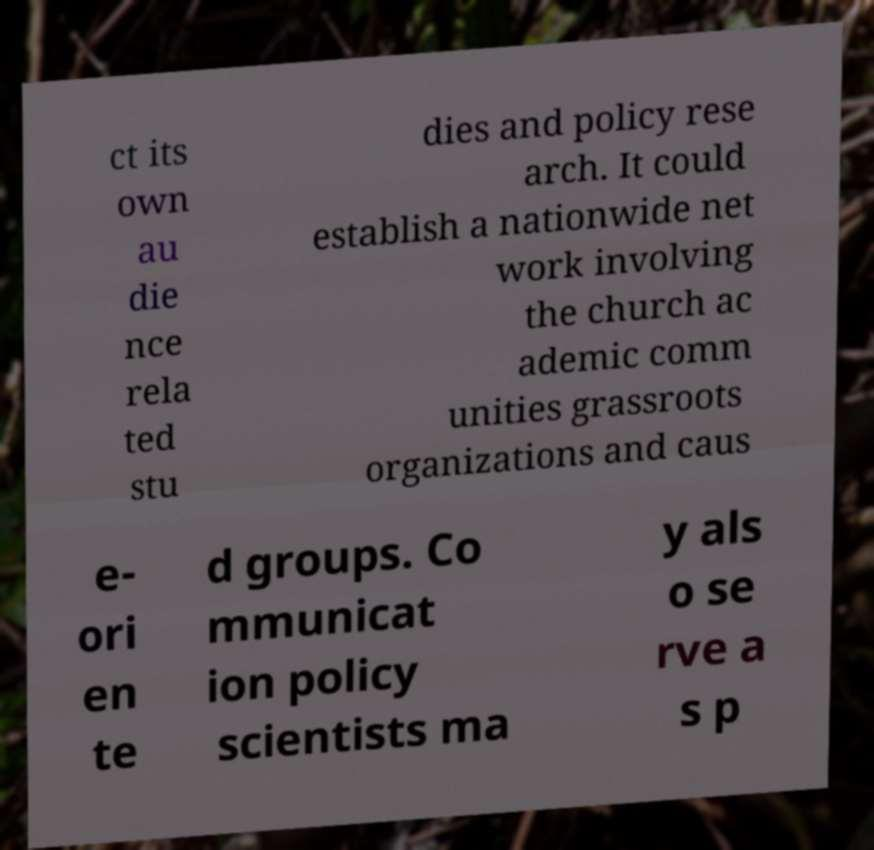What messages or text are displayed in this image? I need them in a readable, typed format. ct its own au die nce rela ted stu dies and policy rese arch. It could establish a nationwide net work involving the church ac ademic comm unities grassroots organizations and caus e- ori en te d groups. Co mmunicat ion policy scientists ma y als o se rve a s p 